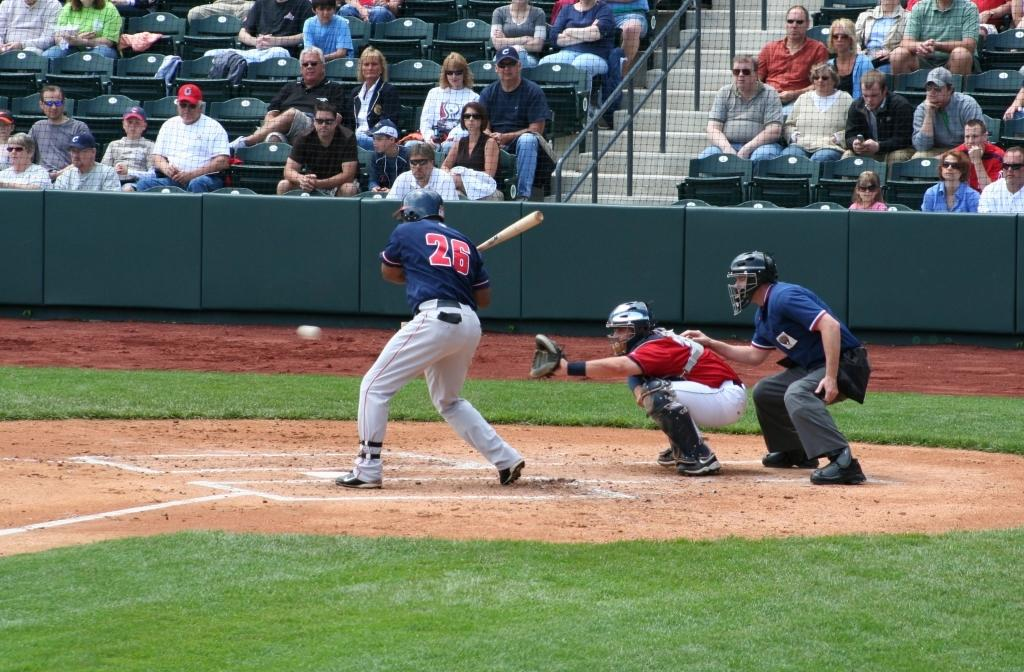Provide a one-sentence caption for the provided image. Player wearing number 26 getting ready to bat. 